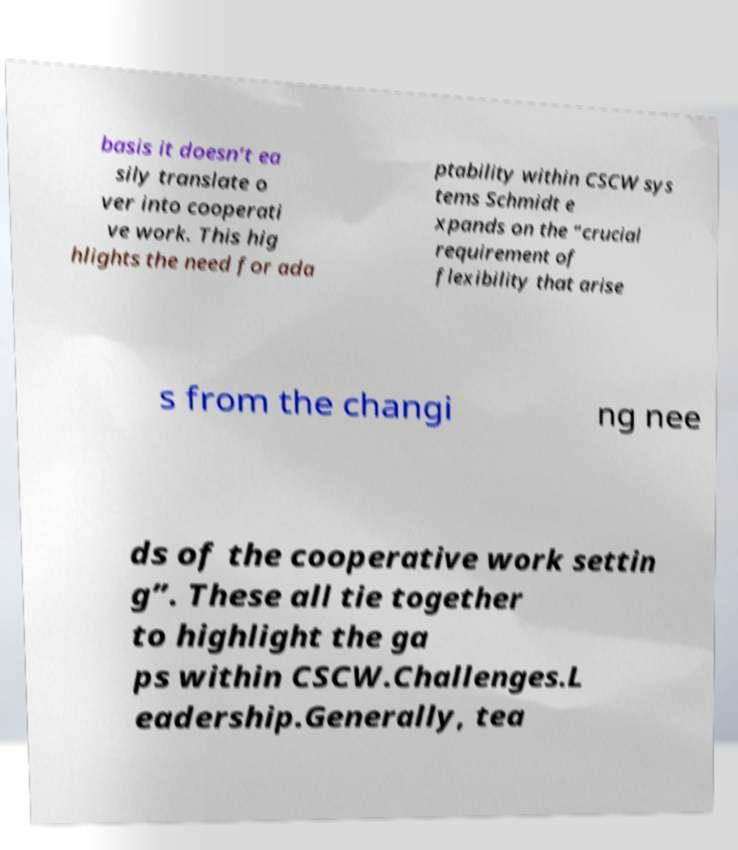Can you accurately transcribe the text from the provided image for me? basis it doesn’t ea sily translate o ver into cooperati ve work. This hig hlights the need for ada ptability within CSCW sys tems Schmidt e xpands on the “crucial requirement of flexibility that arise s from the changi ng nee ds of the cooperative work settin g”. These all tie together to highlight the ga ps within CSCW.Challenges.L eadership.Generally, tea 